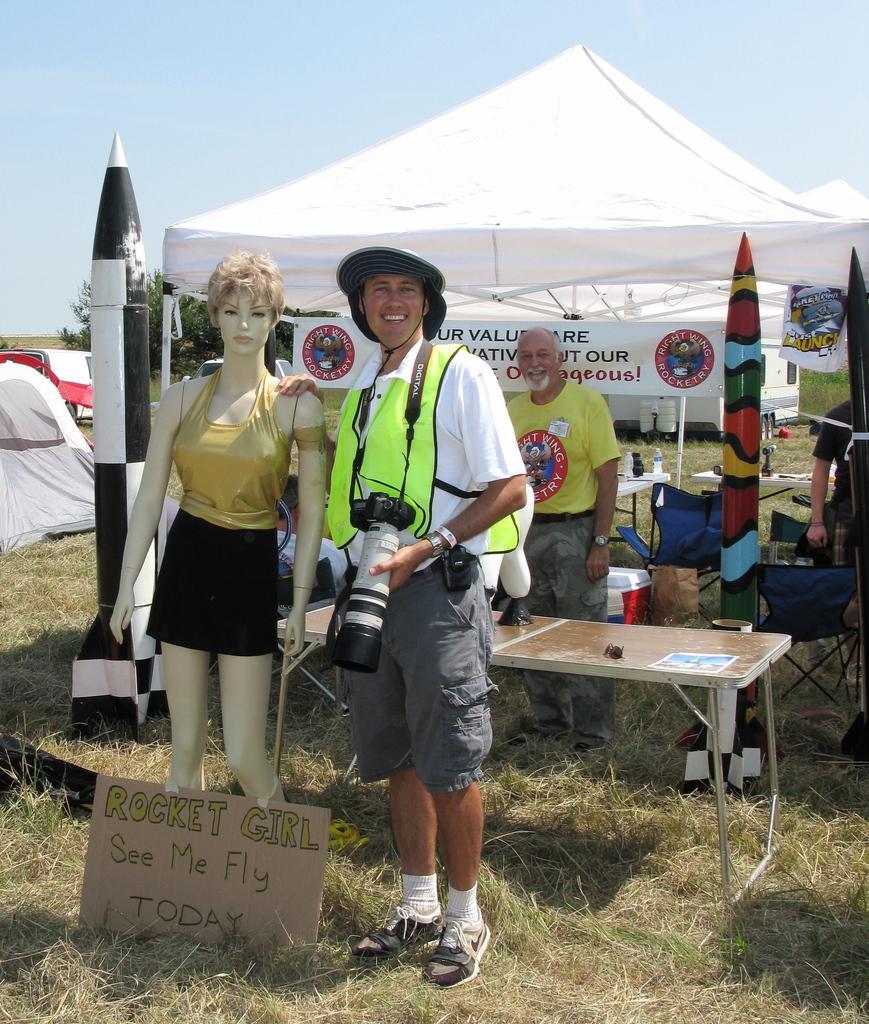How would you summarize this image in a sentence or two? This person wore hat and holding a camera. Beside this person there is a mannequin and an information board. Background there are tents, tables, rocket, boards, person, trees, bottles, hoarding and things. Sky is in blue color. Land is covered with grass. 